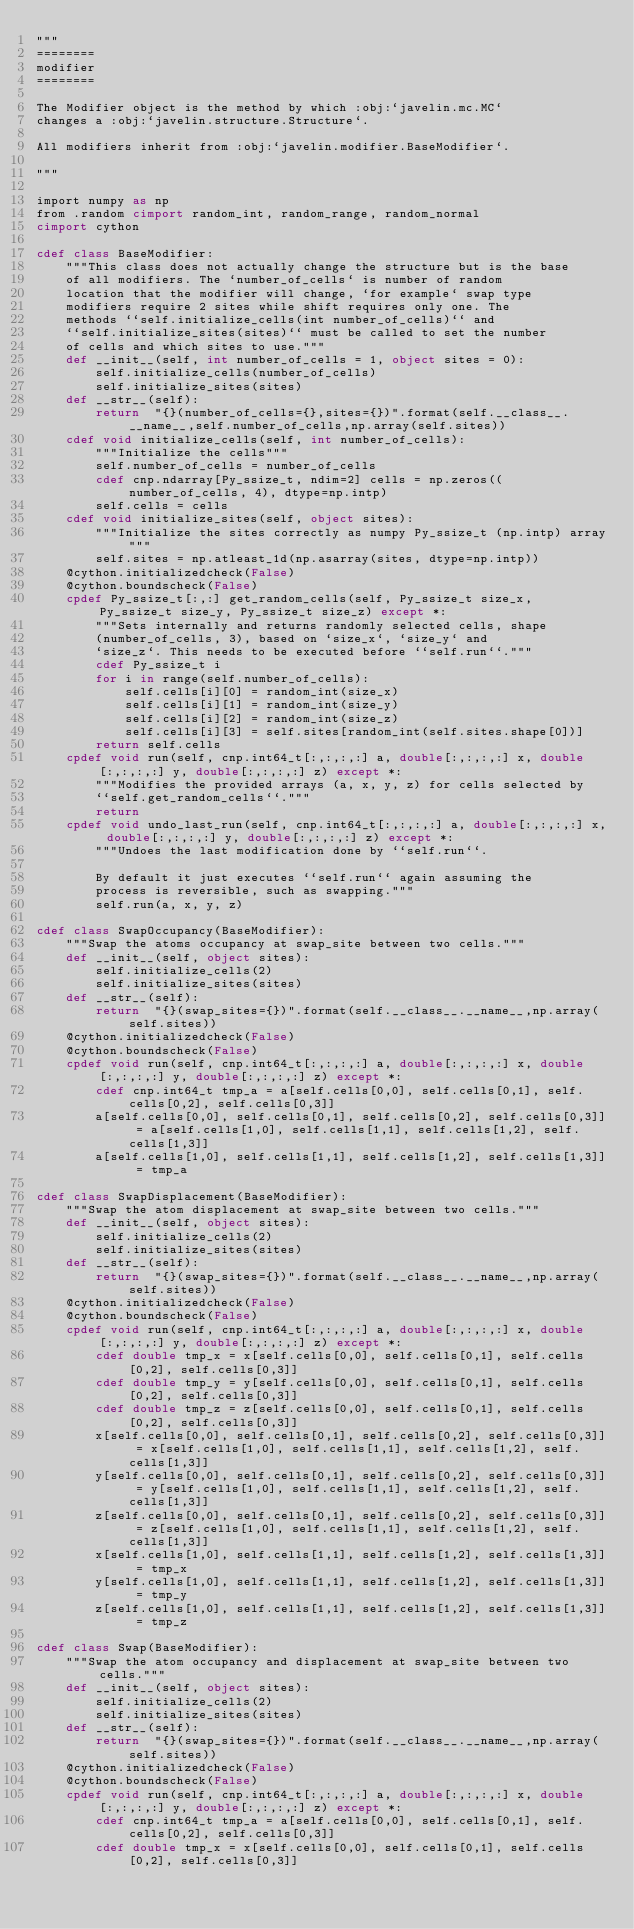Convert code to text. <code><loc_0><loc_0><loc_500><loc_500><_Cython_>"""
========
modifier
========

The Modifier object is the method by which :obj:`javelin.mc.MC`
changes a :obj:`javelin.structure.Structure`.

All modifiers inherit from :obj:`javelin.modifier.BaseModifier`.

"""

import numpy as np
from .random cimport random_int, random_range, random_normal
cimport cython

cdef class BaseModifier:
    """This class does not actually change the structure but is the base
    of all modifiers. The `number_of_cells` is number of random
    location that the modifier will change, `for example` swap type
    modifiers require 2 sites while shift requires only one. The
    methods ``self.initialize_cells(int number_of_cells)`` and
    ``self.initialize_sites(sites)`` must be called to set the number
    of cells and which sites to use."""
    def __init__(self, int number_of_cells = 1, object sites = 0):
        self.initialize_cells(number_of_cells)
        self.initialize_sites(sites)
    def __str__(self):
        return  "{}(number_of_cells={},sites={})".format(self.__class__.__name__,self.number_of_cells,np.array(self.sites))
    cdef void initialize_cells(self, int number_of_cells):
        """Initialize the cells"""
        self.number_of_cells = number_of_cells
        cdef cnp.ndarray[Py_ssize_t, ndim=2] cells = np.zeros((number_of_cells, 4), dtype=np.intp)
        self.cells = cells
    cdef void initialize_sites(self, object sites):
        """Initialize the sites correctly as numpy Py_ssize_t (np.intp) array"""
        self.sites = np.atleast_1d(np.asarray(sites, dtype=np.intp))
    @cython.initializedcheck(False)
    @cython.boundscheck(False)
    cpdef Py_ssize_t[:,:] get_random_cells(self, Py_ssize_t size_x, Py_ssize_t size_y, Py_ssize_t size_z) except *:
        """Sets internally and returns randomly selected cells, shape
        (number_of_cells, 3), based on `size_x`, `size_y` and
        `size_z`. This needs to be executed before ``self.run``."""
        cdef Py_ssize_t i
        for i in range(self.number_of_cells):
            self.cells[i][0] = random_int(size_x)
            self.cells[i][1] = random_int(size_y)
            self.cells[i][2] = random_int(size_z)
            self.cells[i][3] = self.sites[random_int(self.sites.shape[0])]
        return self.cells
    cpdef void run(self, cnp.int64_t[:,:,:,:] a, double[:,:,:,:] x, double[:,:,:,:] y, double[:,:,:,:] z) except *:
        """Modifies the provided arrays (a, x, y, z) for cells selected by
        ``self.get_random_cells``."""
        return
    cpdef void undo_last_run(self, cnp.int64_t[:,:,:,:] a, double[:,:,:,:] x, double[:,:,:,:] y, double[:,:,:,:] z) except *:
        """Undoes the last modification done by ``self.run``.

        By default it just executes ``self.run`` again assuming the
        process is reversible, such as swapping."""
        self.run(a, x, y, z)

cdef class SwapOccupancy(BaseModifier):
    """Swap the atoms occupancy at swap_site between two cells."""
    def __init__(self, object sites):
        self.initialize_cells(2)
        self.initialize_sites(sites)
    def __str__(self):
        return  "{}(swap_sites={})".format(self.__class__.__name__,np.array(self.sites))
    @cython.initializedcheck(False)
    @cython.boundscheck(False)
    cpdef void run(self, cnp.int64_t[:,:,:,:] a, double[:,:,:,:] x, double[:,:,:,:] y, double[:,:,:,:] z) except *:
        cdef cnp.int64_t tmp_a = a[self.cells[0,0], self.cells[0,1], self.cells[0,2], self.cells[0,3]]
        a[self.cells[0,0], self.cells[0,1], self.cells[0,2], self.cells[0,3]] = a[self.cells[1,0], self.cells[1,1], self.cells[1,2], self.cells[1,3]]
        a[self.cells[1,0], self.cells[1,1], self.cells[1,2], self.cells[1,3]] = tmp_a

cdef class SwapDisplacement(BaseModifier):
    """Swap the atom displacement at swap_site between two cells."""
    def __init__(self, object sites):
        self.initialize_cells(2)
        self.initialize_sites(sites)
    def __str__(self):
        return  "{}(swap_sites={})".format(self.__class__.__name__,np.array(self.sites))
    @cython.initializedcheck(False)
    @cython.boundscheck(False)
    cpdef void run(self, cnp.int64_t[:,:,:,:] a, double[:,:,:,:] x, double[:,:,:,:] y, double[:,:,:,:] z) except *:
        cdef double tmp_x = x[self.cells[0,0], self.cells[0,1], self.cells[0,2], self.cells[0,3]]
        cdef double tmp_y = y[self.cells[0,0], self.cells[0,1], self.cells[0,2], self.cells[0,3]]
        cdef double tmp_z = z[self.cells[0,0], self.cells[0,1], self.cells[0,2], self.cells[0,3]]
        x[self.cells[0,0], self.cells[0,1], self.cells[0,2], self.cells[0,3]] = x[self.cells[1,0], self.cells[1,1], self.cells[1,2], self.cells[1,3]]
        y[self.cells[0,0], self.cells[0,1], self.cells[0,2], self.cells[0,3]] = y[self.cells[1,0], self.cells[1,1], self.cells[1,2], self.cells[1,3]]
        z[self.cells[0,0], self.cells[0,1], self.cells[0,2], self.cells[0,3]] = z[self.cells[1,0], self.cells[1,1], self.cells[1,2], self.cells[1,3]]
        x[self.cells[1,0], self.cells[1,1], self.cells[1,2], self.cells[1,3]] = tmp_x
        y[self.cells[1,0], self.cells[1,1], self.cells[1,2], self.cells[1,3]] = tmp_y
        z[self.cells[1,0], self.cells[1,1], self.cells[1,2], self.cells[1,3]] = tmp_z

cdef class Swap(BaseModifier):
    """Swap the atom occupancy and displacement at swap_site between two cells."""
    def __init__(self, object sites):
        self.initialize_cells(2)
        self.initialize_sites(sites)
    def __str__(self):
        return  "{}(swap_sites={})".format(self.__class__.__name__,np.array(self.sites))
    @cython.initializedcheck(False)
    @cython.boundscheck(False)
    cpdef void run(self, cnp.int64_t[:,:,:,:] a, double[:,:,:,:] x, double[:,:,:,:] y, double[:,:,:,:] z) except *:
        cdef cnp.int64_t tmp_a = a[self.cells[0,0], self.cells[0,1], self.cells[0,2], self.cells[0,3]]
        cdef double tmp_x = x[self.cells[0,0], self.cells[0,1], self.cells[0,2], self.cells[0,3]]</code> 